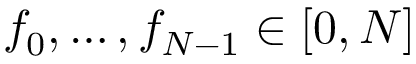<formula> <loc_0><loc_0><loc_500><loc_500>f _ { 0 } , \dots , f _ { N - 1 } \in [ 0 , N ]</formula> 